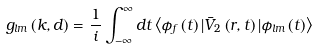Convert formula to latex. <formula><loc_0><loc_0><loc_500><loc_500>g _ { l m } \left ( k , d \right ) = \frac { 1 } { i } \int _ { - \infty } ^ { \infty } d t \left \langle \phi _ { f } \left ( t \right ) | \bar { V } _ { 2 } \left ( r , t \right ) | \phi _ { l m } \left ( t \right ) \right \rangle</formula> 